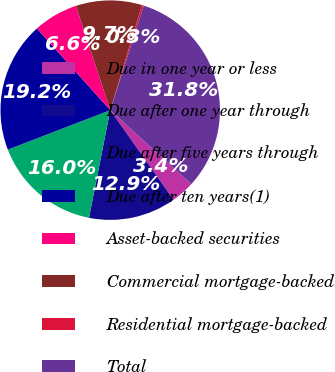Convert chart. <chart><loc_0><loc_0><loc_500><loc_500><pie_chart><fcel>Due in one year or less<fcel>Due after one year through<fcel>Due after five years through<fcel>Due after ten years(1)<fcel>Asset-backed securities<fcel>Commercial mortgage-backed<fcel>Residential mortgage-backed<fcel>Total<nl><fcel>3.43%<fcel>12.89%<fcel>16.05%<fcel>19.21%<fcel>6.58%<fcel>9.74%<fcel>0.27%<fcel>31.83%<nl></chart> 